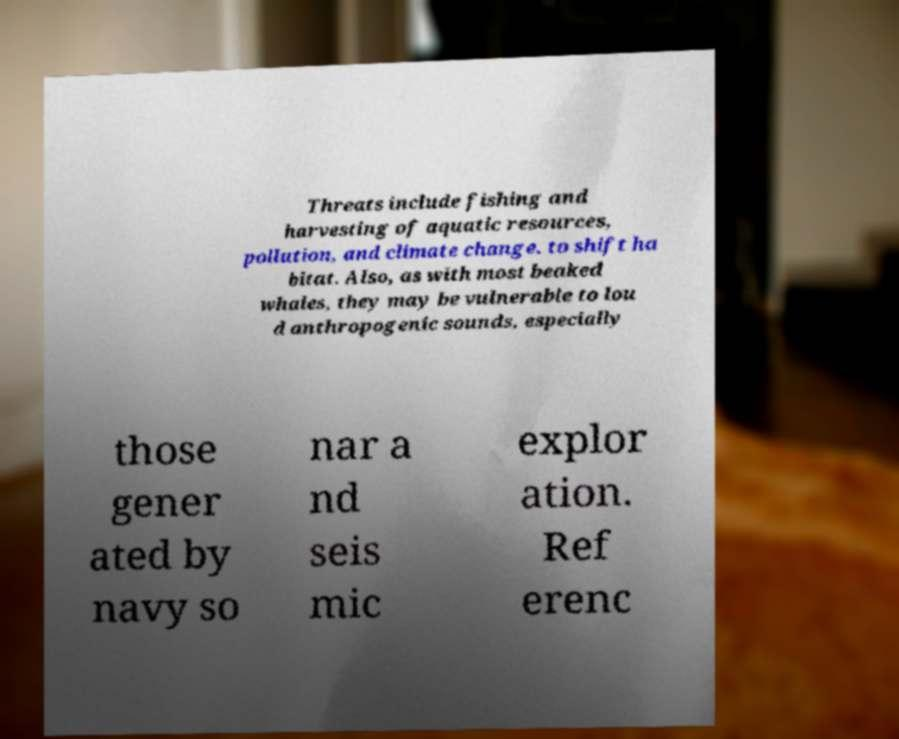For documentation purposes, I need the text within this image transcribed. Could you provide that? Threats include fishing and harvesting of aquatic resources, pollution, and climate change. to shift ha bitat. Also, as with most beaked whales, they may be vulnerable to lou d anthropogenic sounds, especially those gener ated by navy so nar a nd seis mic explor ation. Ref erenc 